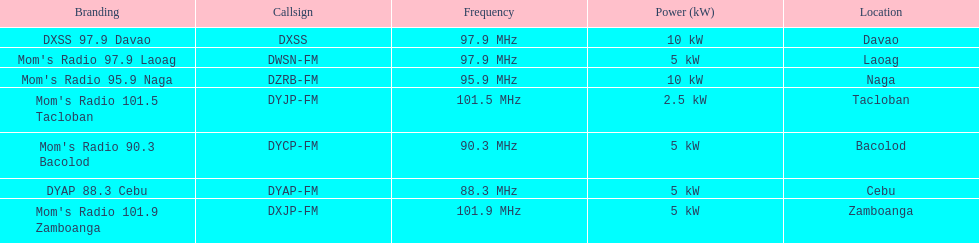What are the total number of radio stations on this list? 7. 